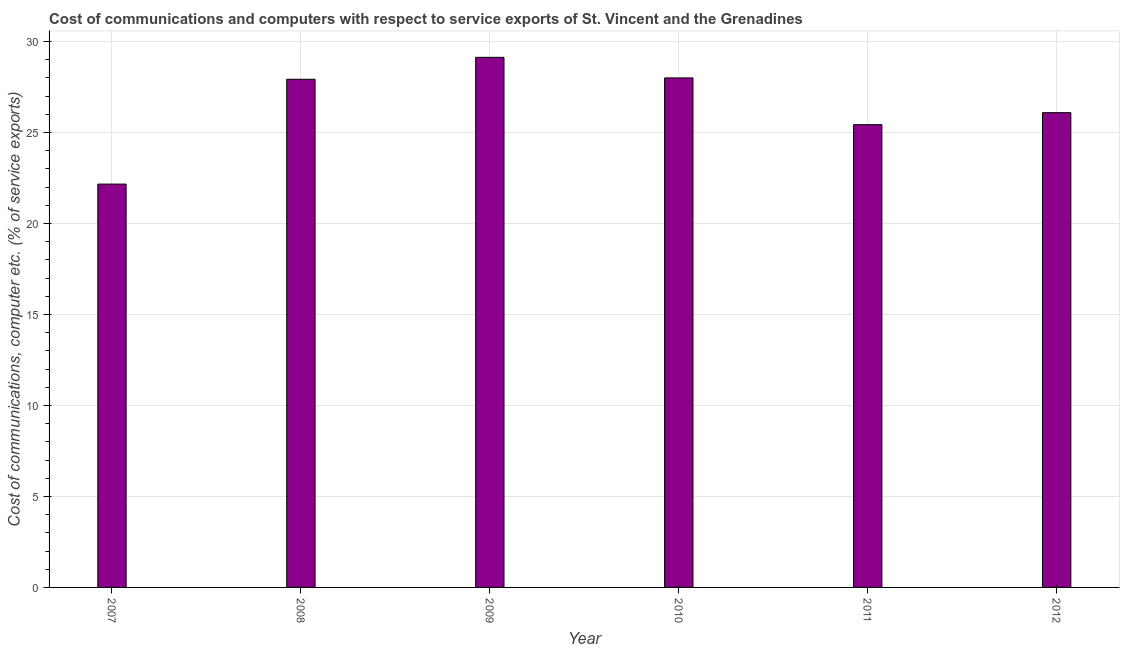Does the graph contain any zero values?
Your answer should be very brief. No. What is the title of the graph?
Make the answer very short. Cost of communications and computers with respect to service exports of St. Vincent and the Grenadines. What is the label or title of the X-axis?
Make the answer very short. Year. What is the label or title of the Y-axis?
Make the answer very short. Cost of communications, computer etc. (% of service exports). What is the cost of communications and computer in 2011?
Your answer should be compact. 25.43. Across all years, what is the maximum cost of communications and computer?
Keep it short and to the point. 29.14. Across all years, what is the minimum cost of communications and computer?
Keep it short and to the point. 22.17. What is the sum of the cost of communications and computer?
Your answer should be compact. 158.76. What is the difference between the cost of communications and computer in 2009 and 2012?
Your response must be concise. 3.04. What is the average cost of communications and computer per year?
Your answer should be compact. 26.46. What is the median cost of communications and computer?
Offer a terse response. 27.01. What is the ratio of the cost of communications and computer in 2007 to that in 2008?
Provide a short and direct response. 0.79. Is the difference between the cost of communications and computer in 2009 and 2010 greater than the difference between any two years?
Give a very brief answer. No. What is the difference between the highest and the second highest cost of communications and computer?
Your response must be concise. 1.13. Is the sum of the cost of communications and computer in 2008 and 2009 greater than the maximum cost of communications and computer across all years?
Ensure brevity in your answer.  Yes. What is the difference between the highest and the lowest cost of communications and computer?
Make the answer very short. 6.97. In how many years, is the cost of communications and computer greater than the average cost of communications and computer taken over all years?
Your response must be concise. 3. How many bars are there?
Give a very brief answer. 6. Are all the bars in the graph horizontal?
Provide a succinct answer. No. How many years are there in the graph?
Your answer should be very brief. 6. Are the values on the major ticks of Y-axis written in scientific E-notation?
Your answer should be compact. No. What is the Cost of communications, computer etc. (% of service exports) in 2007?
Your answer should be compact. 22.17. What is the Cost of communications, computer etc. (% of service exports) in 2008?
Your response must be concise. 27.93. What is the Cost of communications, computer etc. (% of service exports) of 2009?
Provide a short and direct response. 29.14. What is the Cost of communications, computer etc. (% of service exports) in 2010?
Keep it short and to the point. 28. What is the Cost of communications, computer etc. (% of service exports) of 2011?
Offer a very short reply. 25.43. What is the Cost of communications, computer etc. (% of service exports) of 2012?
Your answer should be compact. 26.09. What is the difference between the Cost of communications, computer etc. (% of service exports) in 2007 and 2008?
Offer a very short reply. -5.76. What is the difference between the Cost of communications, computer etc. (% of service exports) in 2007 and 2009?
Offer a terse response. -6.97. What is the difference between the Cost of communications, computer etc. (% of service exports) in 2007 and 2010?
Offer a very short reply. -5.83. What is the difference between the Cost of communications, computer etc. (% of service exports) in 2007 and 2011?
Your answer should be very brief. -3.27. What is the difference between the Cost of communications, computer etc. (% of service exports) in 2007 and 2012?
Keep it short and to the point. -3.92. What is the difference between the Cost of communications, computer etc. (% of service exports) in 2008 and 2009?
Offer a terse response. -1.21. What is the difference between the Cost of communications, computer etc. (% of service exports) in 2008 and 2010?
Offer a terse response. -0.07. What is the difference between the Cost of communications, computer etc. (% of service exports) in 2008 and 2011?
Give a very brief answer. 2.5. What is the difference between the Cost of communications, computer etc. (% of service exports) in 2008 and 2012?
Make the answer very short. 1.84. What is the difference between the Cost of communications, computer etc. (% of service exports) in 2009 and 2010?
Ensure brevity in your answer.  1.13. What is the difference between the Cost of communications, computer etc. (% of service exports) in 2009 and 2011?
Ensure brevity in your answer.  3.7. What is the difference between the Cost of communications, computer etc. (% of service exports) in 2009 and 2012?
Offer a very short reply. 3.04. What is the difference between the Cost of communications, computer etc. (% of service exports) in 2010 and 2011?
Keep it short and to the point. 2.57. What is the difference between the Cost of communications, computer etc. (% of service exports) in 2010 and 2012?
Provide a short and direct response. 1.91. What is the difference between the Cost of communications, computer etc. (% of service exports) in 2011 and 2012?
Offer a very short reply. -0.66. What is the ratio of the Cost of communications, computer etc. (% of service exports) in 2007 to that in 2008?
Offer a terse response. 0.79. What is the ratio of the Cost of communications, computer etc. (% of service exports) in 2007 to that in 2009?
Offer a terse response. 0.76. What is the ratio of the Cost of communications, computer etc. (% of service exports) in 2007 to that in 2010?
Your answer should be compact. 0.79. What is the ratio of the Cost of communications, computer etc. (% of service exports) in 2007 to that in 2011?
Keep it short and to the point. 0.87. What is the ratio of the Cost of communications, computer etc. (% of service exports) in 2007 to that in 2012?
Provide a short and direct response. 0.85. What is the ratio of the Cost of communications, computer etc. (% of service exports) in 2008 to that in 2010?
Your response must be concise. 1. What is the ratio of the Cost of communications, computer etc. (% of service exports) in 2008 to that in 2011?
Provide a succinct answer. 1.1. What is the ratio of the Cost of communications, computer etc. (% of service exports) in 2008 to that in 2012?
Provide a short and direct response. 1.07. What is the ratio of the Cost of communications, computer etc. (% of service exports) in 2009 to that in 2011?
Offer a terse response. 1.15. What is the ratio of the Cost of communications, computer etc. (% of service exports) in 2009 to that in 2012?
Keep it short and to the point. 1.12. What is the ratio of the Cost of communications, computer etc. (% of service exports) in 2010 to that in 2011?
Offer a very short reply. 1.1. What is the ratio of the Cost of communications, computer etc. (% of service exports) in 2010 to that in 2012?
Offer a terse response. 1.07. 